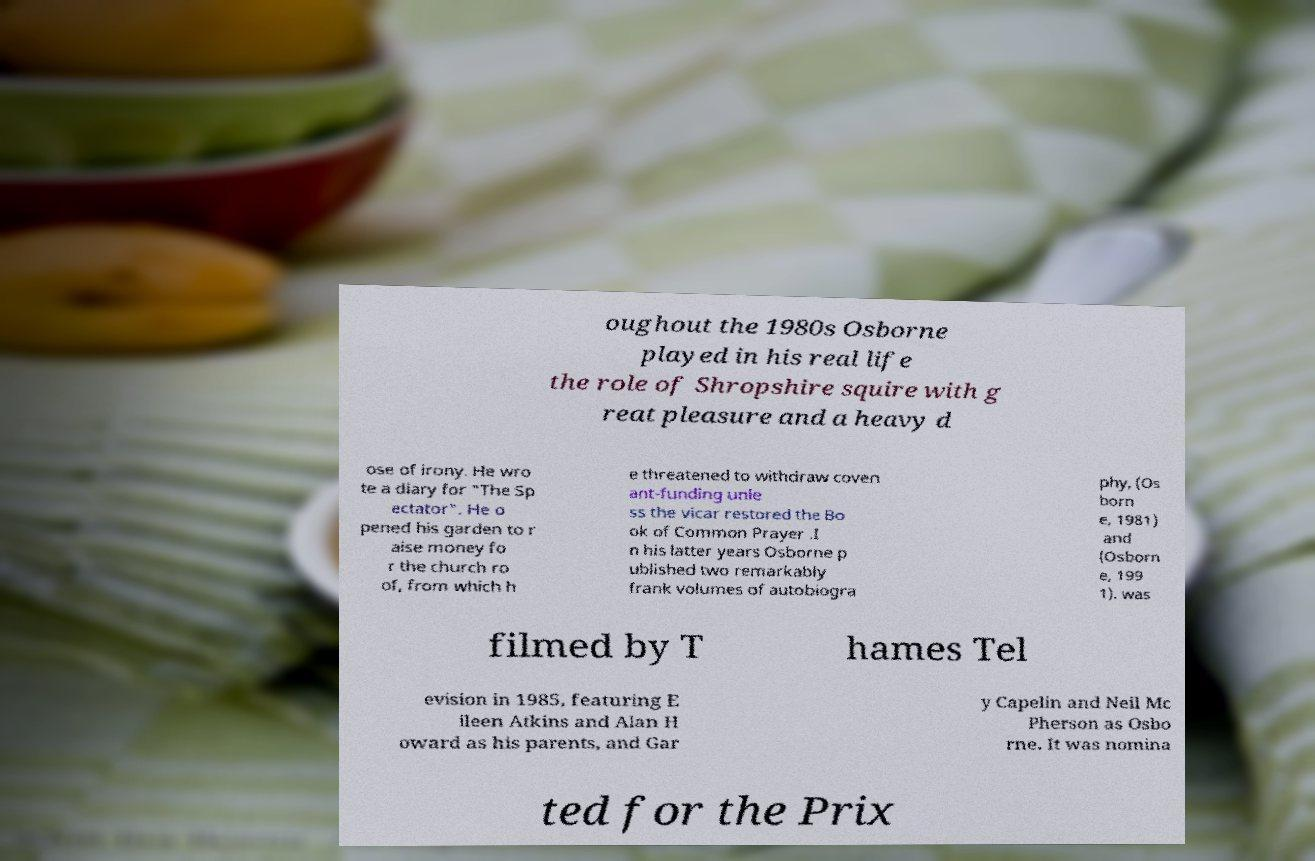Could you extract and type out the text from this image? oughout the 1980s Osborne played in his real life the role of Shropshire squire with g reat pleasure and a heavy d ose of irony. He wro te a diary for "The Sp ectator". He o pened his garden to r aise money fo r the church ro of, from which h e threatened to withdraw coven ant-funding unle ss the vicar restored the Bo ok of Common Prayer .I n his latter years Osborne p ublished two remarkably frank volumes of autobiogra phy, (Os born e, 1981) and (Osborn e, 199 1). was filmed by T hames Tel evision in 1985, featuring E ileen Atkins and Alan H oward as his parents, and Gar y Capelin and Neil Mc Pherson as Osbo rne. It was nomina ted for the Prix 